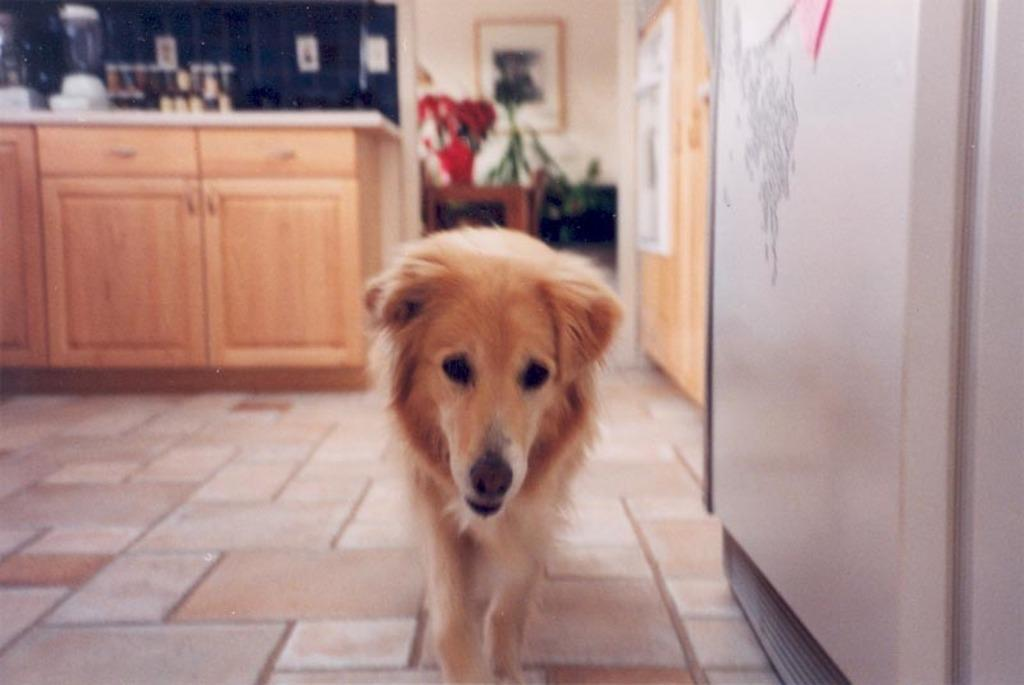What type of animal can be seen in the image? There is a dog in the image. What appliance is present in the image? There is a refrigerator in the image. What type of furniture is in the image? There are cupboards in the image. What kitchen tool is visible in the image? There is a mixer in the image. What architectural feature is present in the image? There is a wall in the image. What object is used for displaying photos in the image? There is a photo frame in the image. How much credit is available for the dog in the image? There is no mention of credit or financial matters in the image; it features a dog, a refrigerator, cupboards, a mixer, a wall, and a photo frame. Where is the mailbox located in the image? There is no mailbox present in the image. 